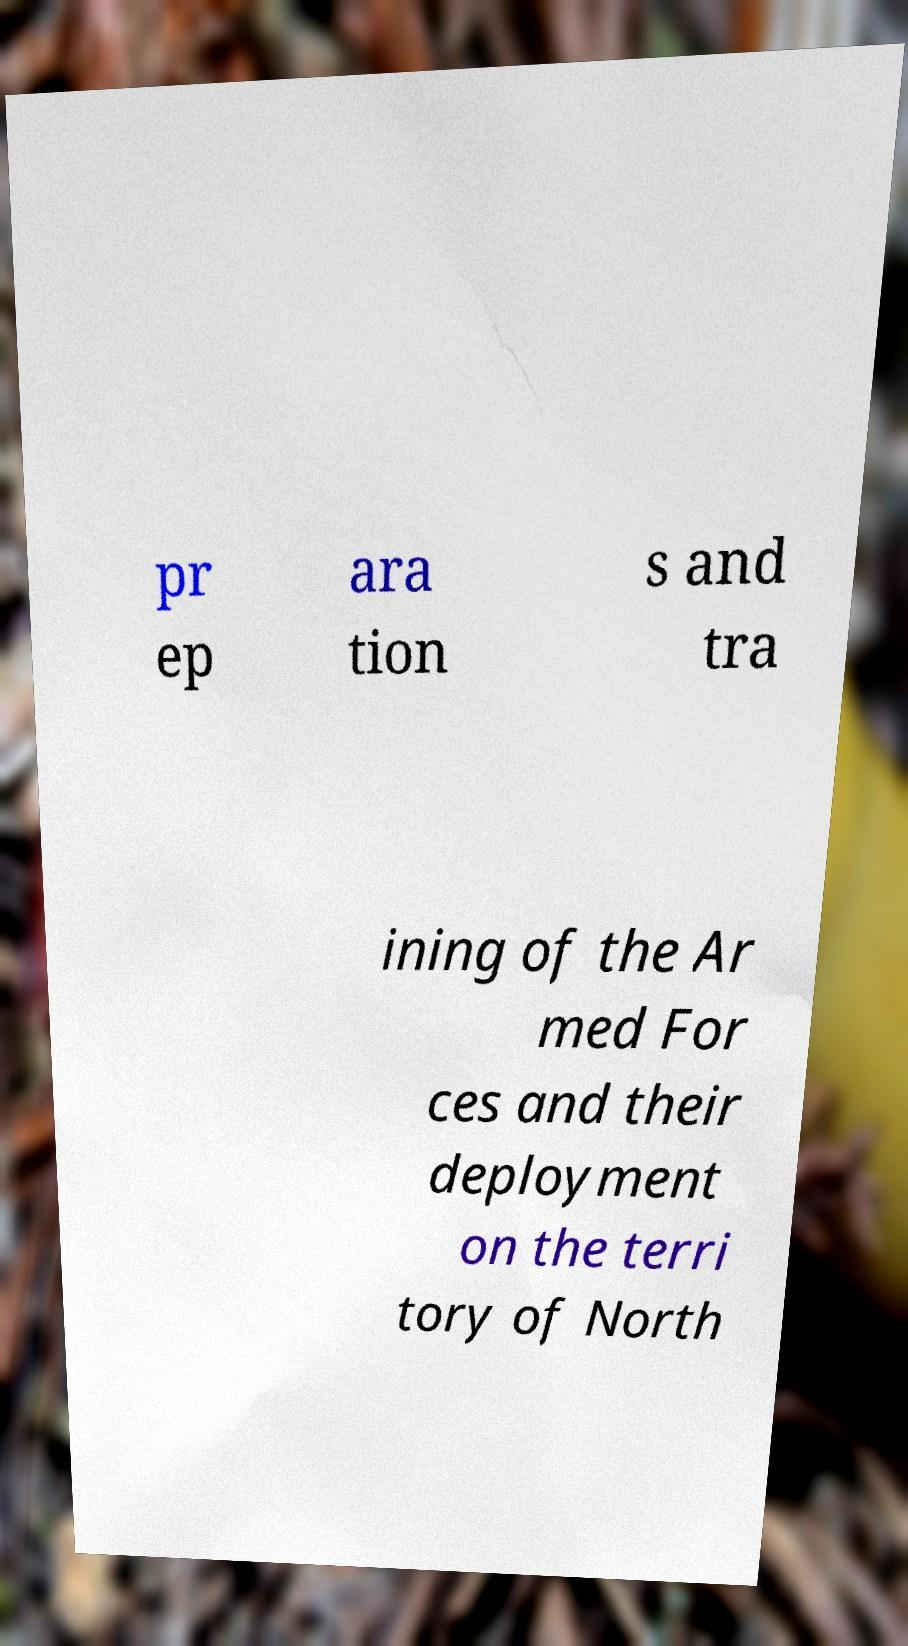Please read and relay the text visible in this image. What does it say? pr ep ara tion s and tra ining of the Ar med For ces and their deployment on the terri tory of North 